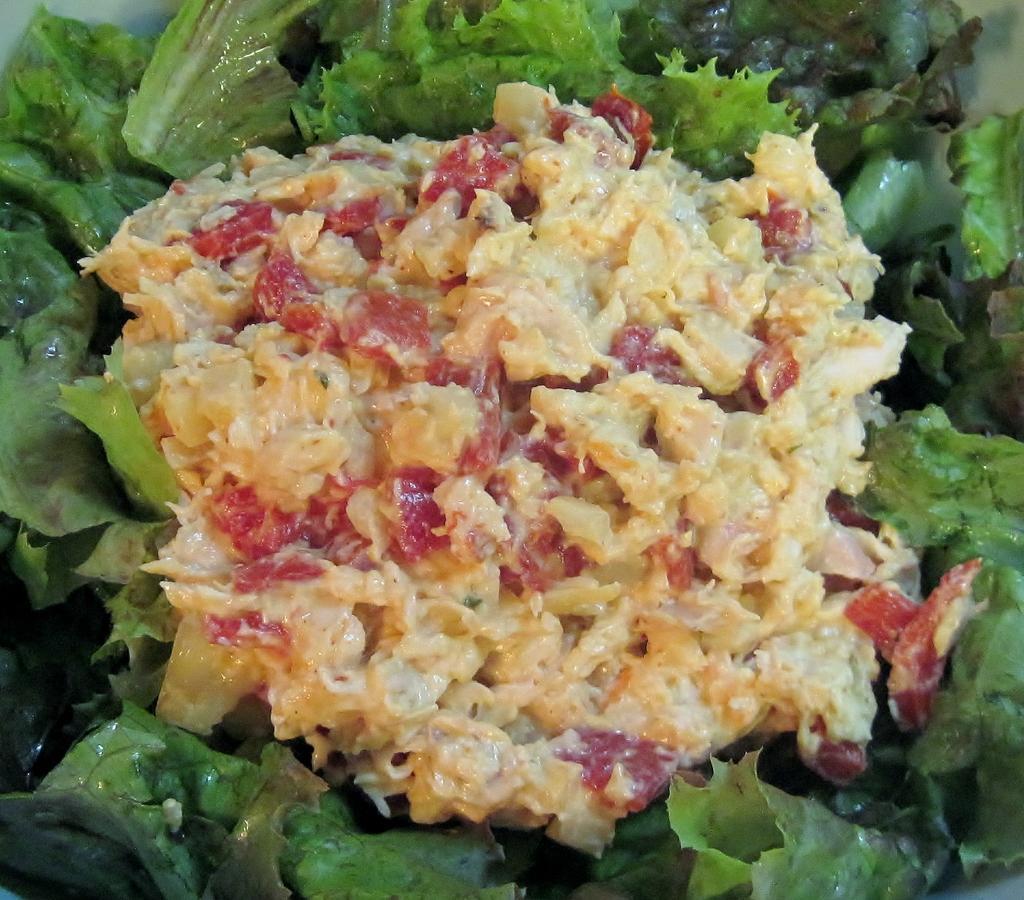Please provide a concise description of this image. In this image in the middle it's look like food, and surround with some green leaves. 